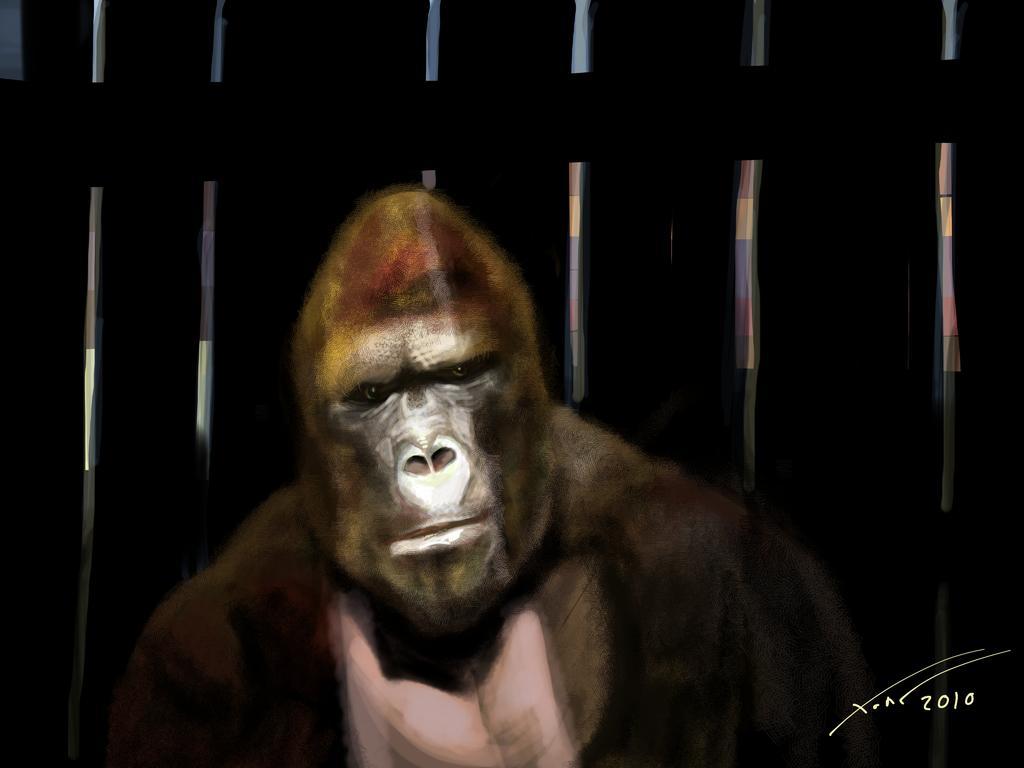Please provide a concise description of this image. In the center of the image we can see the painting, in which we can see a gorilla and a fence. At the bottom right side of the image, we can see some text. 